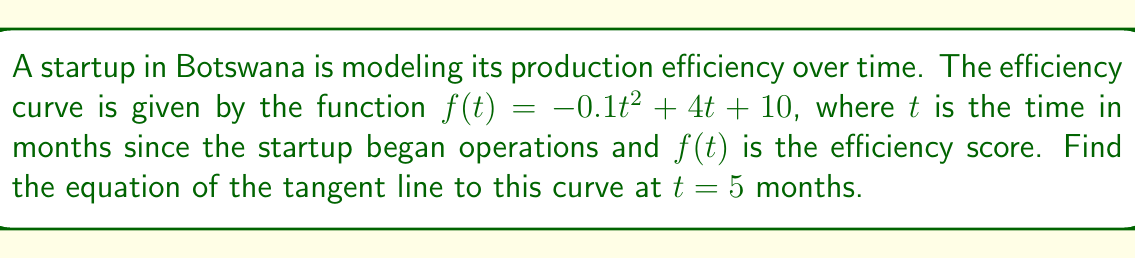What is the answer to this math problem? To find the equation of the tangent line, we need to follow these steps:

1) The general equation of a tangent line is $y - y_0 = m(x - x_0)$, where $(x_0, y_0)$ is the point of tangency and $m$ is the slope of the tangent line.

2) We need to find $y_0$ by evaluating $f(5)$:
   $f(5) = -0.1(5)^2 + 4(5) + 10$
   $= -0.1(25) + 20 + 10$
   $= -2.5 + 20 + 10$
   $= 27.5$

   So, the point of tangency is $(5, 27.5)$.

3) To find the slope $m$, we need to calculate $f'(t)$ and then evaluate it at $t = 5$:
   $f'(t) = -0.2t + 4$
   $f'(5) = -0.2(5) + 4 = -1 + 4 = 3$

4) Now we have all the components to write the equation of the tangent line:
   $y - 27.5 = 3(x - 5)$

5) Simplify:
   $y = 3x - 15 + 27.5$
   $y = 3x + 12.5$

This is the equation of the tangent line in slope-intercept form.
Answer: $y = 3x + 12.5$ 